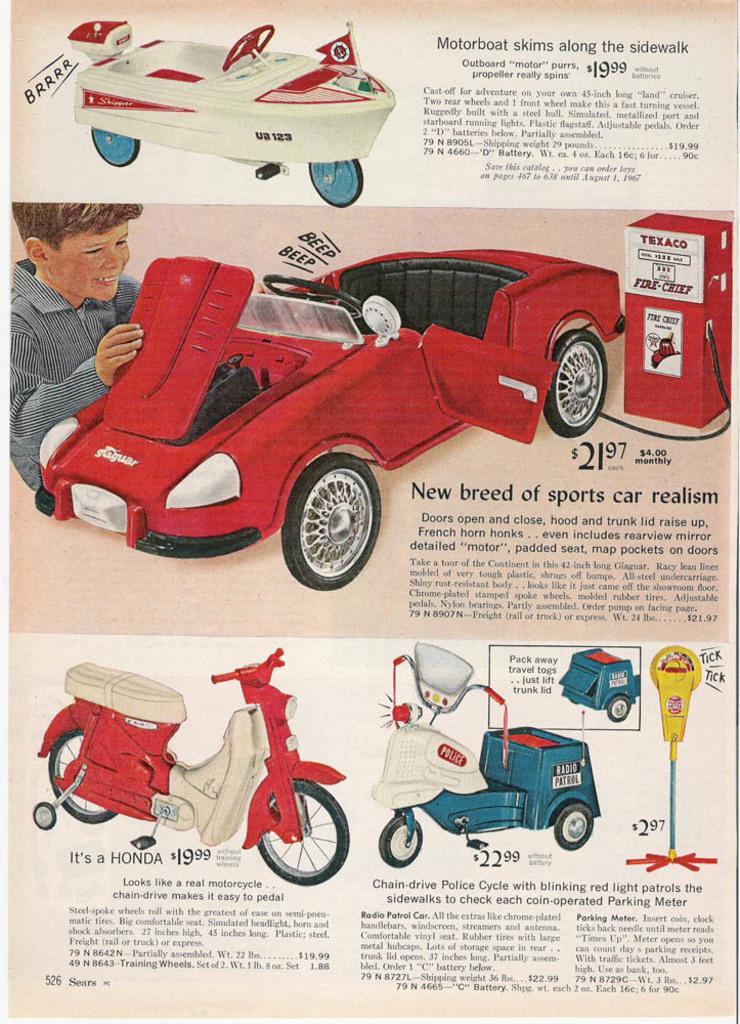In one or two sentences, can you explain what this image depicts? In this picture we can see a paper and on the paper there are some vehicles and other things and on the paper it is written something. 